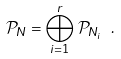<formula> <loc_0><loc_0><loc_500><loc_500>\mathcal { P } _ { N } = \bigoplus _ { i = 1 } ^ { r } \, \mathcal { P } _ { N _ { i } } \ .</formula> 